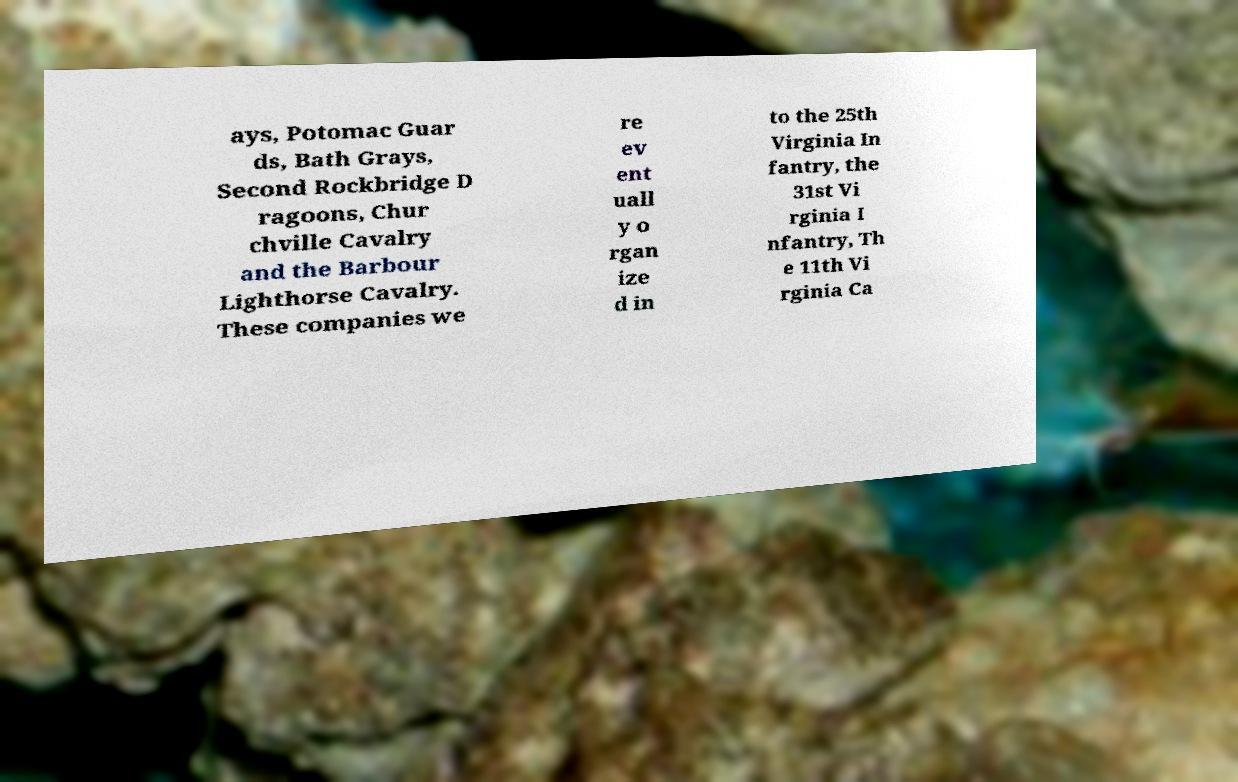Could you assist in decoding the text presented in this image and type it out clearly? ays, Potomac Guar ds, Bath Grays, Second Rockbridge D ragoons, Chur chville Cavalry and the Barbour Lighthorse Cavalry. These companies we re ev ent uall y o rgan ize d in to the 25th Virginia In fantry, the 31st Vi rginia I nfantry, Th e 11th Vi rginia Ca 